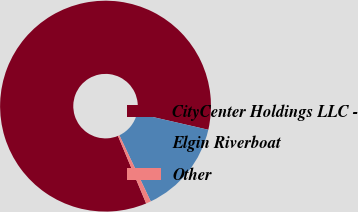<chart> <loc_0><loc_0><loc_500><loc_500><pie_chart><fcel>CityCenter Holdings LLC -<fcel>Elgin Riverboat<fcel>Other<nl><fcel>84.89%<fcel>14.35%<fcel>0.76%<nl></chart> 